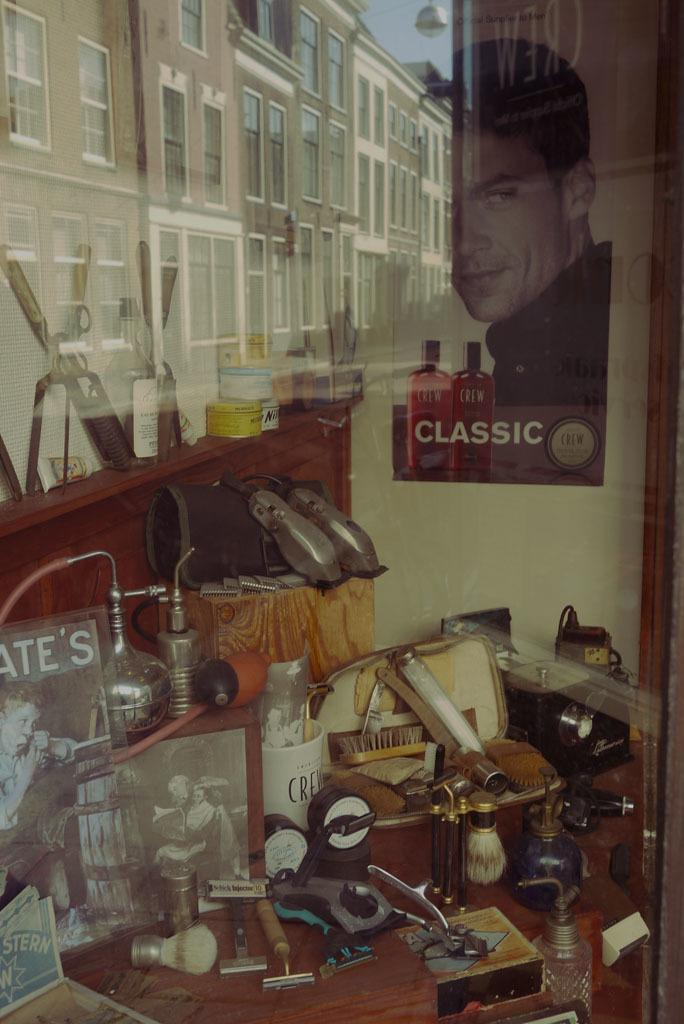Provide a one-sentence caption for the provided image. A table covered in different knicknacks and tools sits next to a poster of a man with the word Classic written at the bottom. 